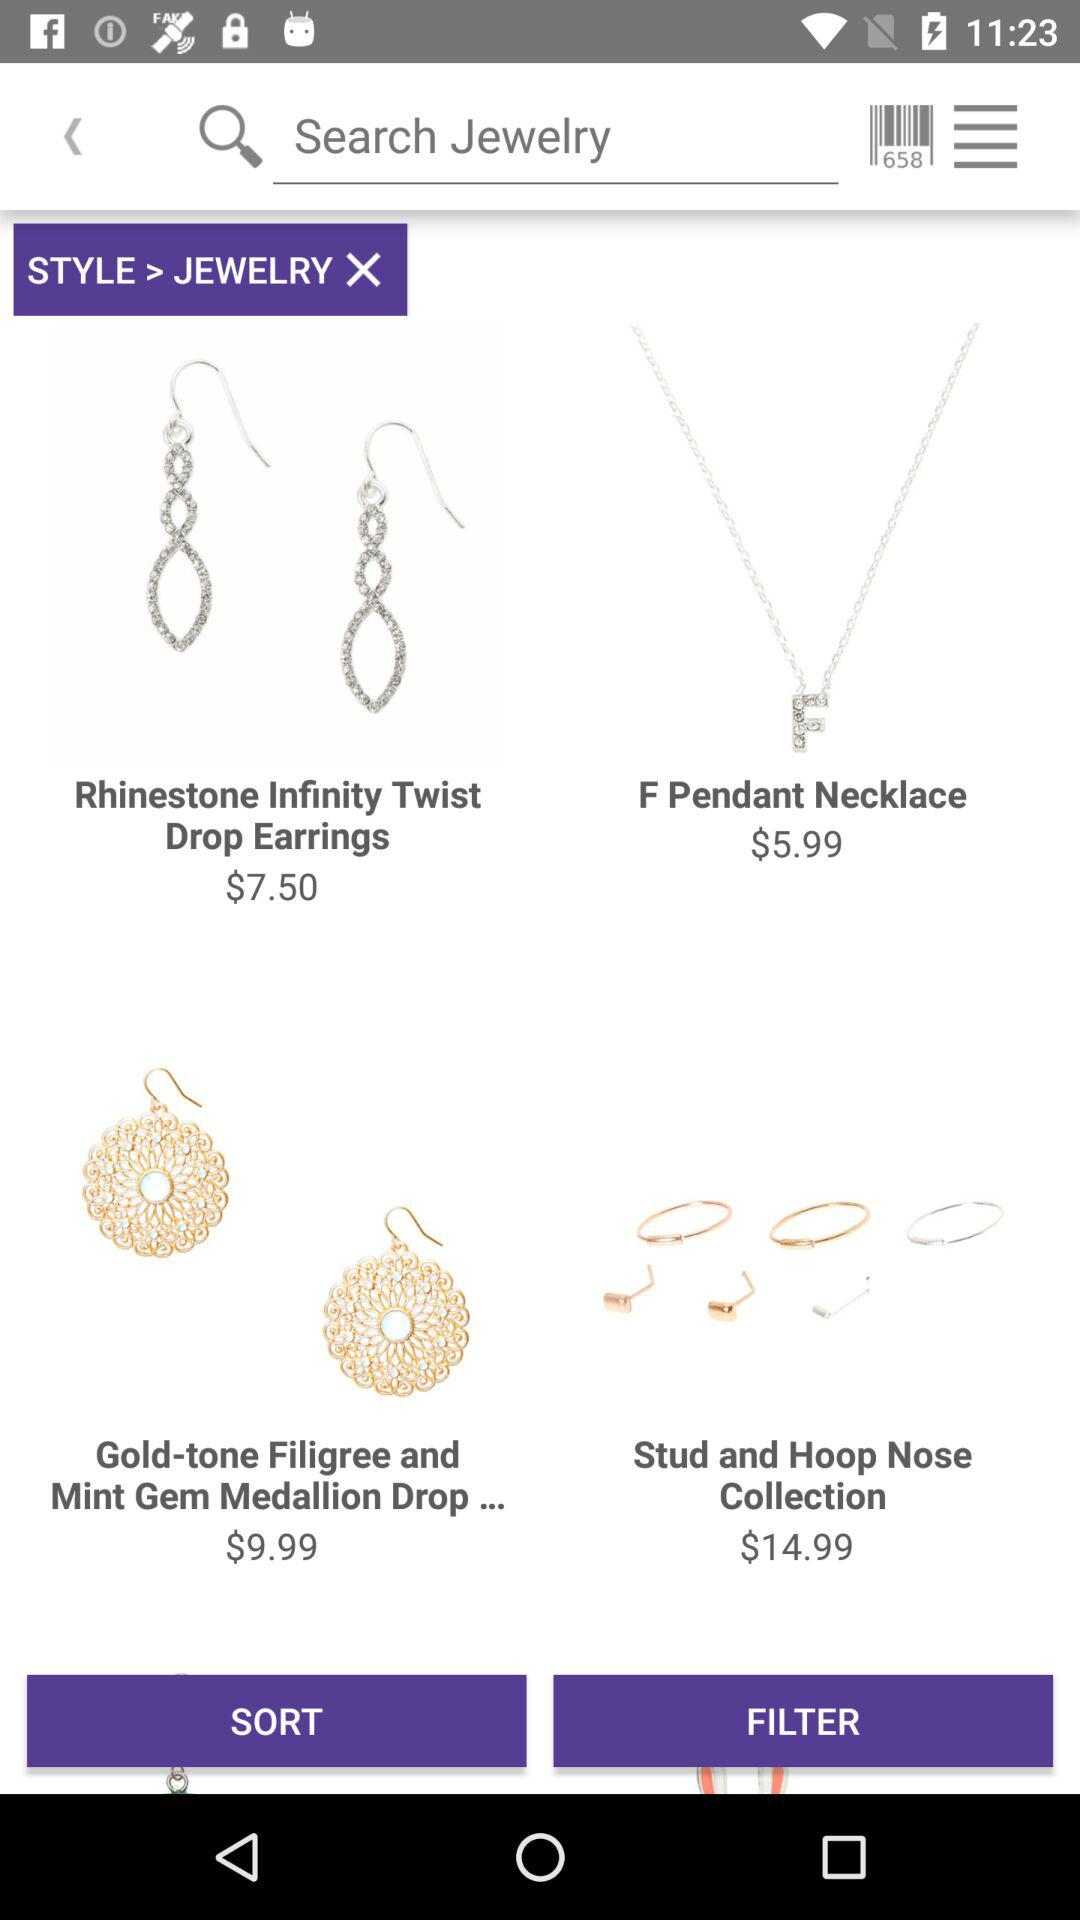What is the price of "Rhinestone Infinity Twist Drop Earrings"? The price of "Rhinestone Infinity Twist Drop Earrings" is $7.50. 